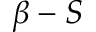Convert formula to latex. <formula><loc_0><loc_0><loc_500><loc_500>\beta - S</formula> 